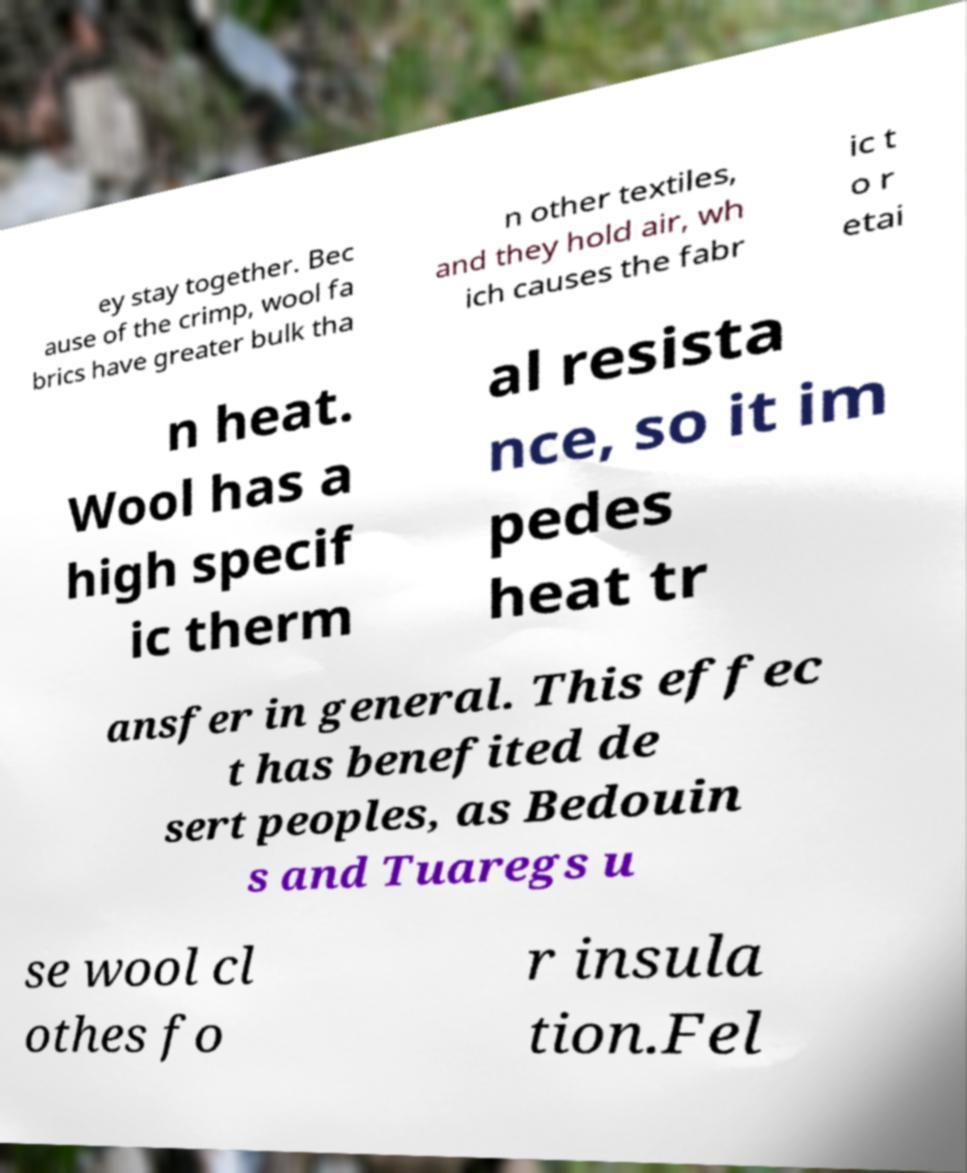There's text embedded in this image that I need extracted. Can you transcribe it verbatim? ey stay together. Bec ause of the crimp, wool fa brics have greater bulk tha n other textiles, and they hold air, wh ich causes the fabr ic t o r etai n heat. Wool has a high specif ic therm al resista nce, so it im pedes heat tr ansfer in general. This effec t has benefited de sert peoples, as Bedouin s and Tuaregs u se wool cl othes fo r insula tion.Fel 